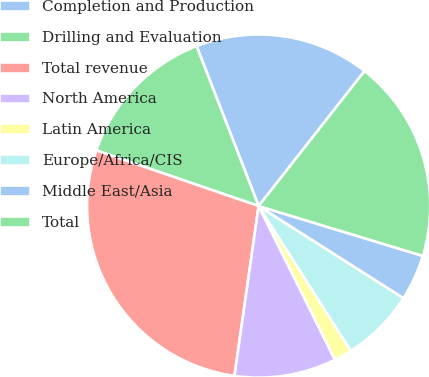Convert chart to OTSL. <chart><loc_0><loc_0><loc_500><loc_500><pie_chart><fcel>Completion and Production<fcel>Drilling and Evaluation<fcel>Total revenue<fcel>North America<fcel>Latin America<fcel>Europe/Africa/CIS<fcel>Middle East/Asia<fcel>Total<nl><fcel>16.48%<fcel>13.85%<fcel>28.01%<fcel>9.59%<fcel>1.69%<fcel>6.96%<fcel>4.32%<fcel>19.11%<nl></chart> 